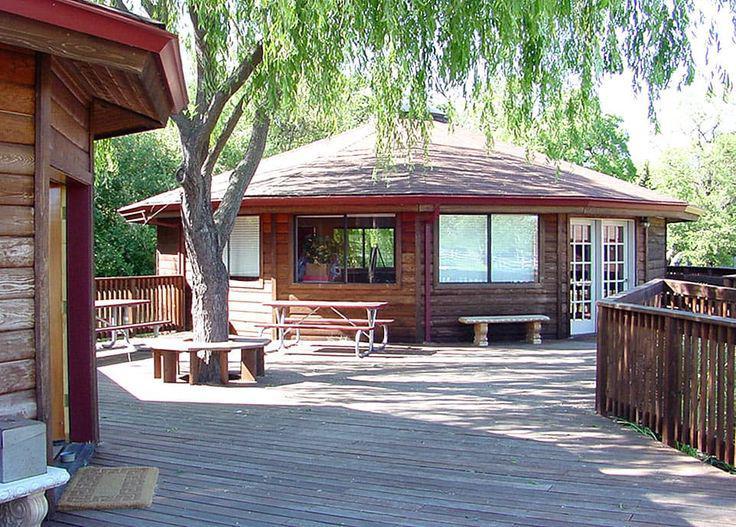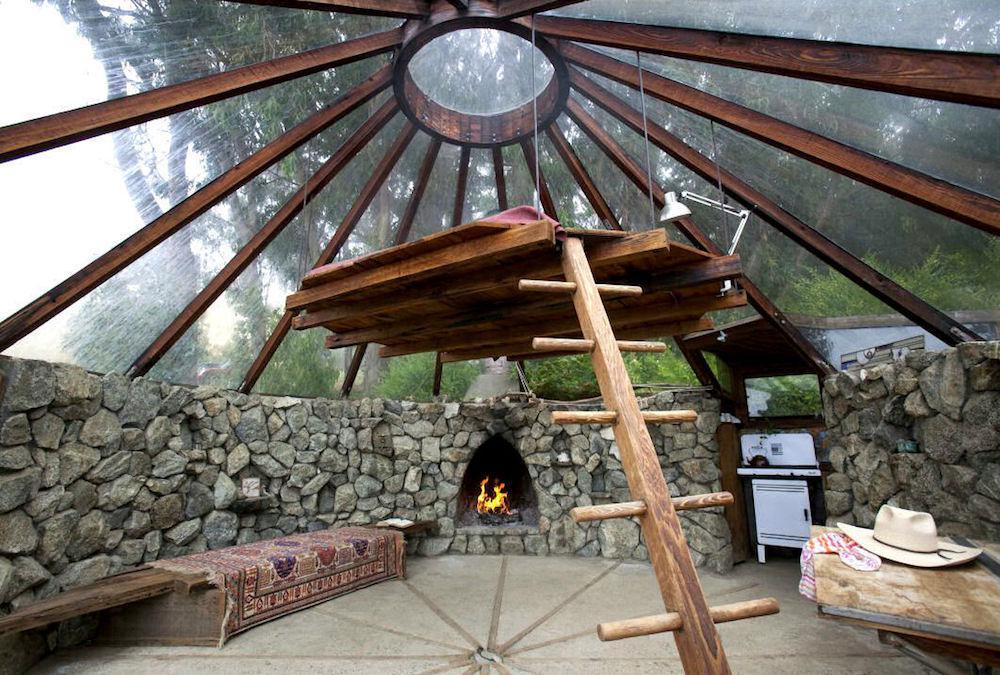The first image is the image on the left, the second image is the image on the right. Given the left and right images, does the statement "In one image, a round wooden house is under construction with an incomplete roof." hold true? Answer yes or no. No. 